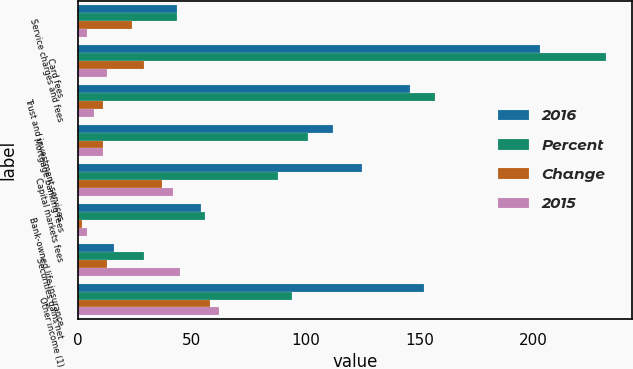Convert chart. <chart><loc_0><loc_0><loc_500><loc_500><stacked_bar_chart><ecel><fcel>Service charges and fees<fcel>Card fees<fcel>Trust and investment services<fcel>Mortgage banking fees<fcel>Capital markets fees<fcel>Bank-owned life insurance<fcel>Securities gains net<fcel>Other income (1)<nl><fcel>2016<fcel>43.5<fcel>203<fcel>146<fcel>112<fcel>125<fcel>54<fcel>16<fcel>152<nl><fcel>Percent<fcel>43.5<fcel>232<fcel>157<fcel>101<fcel>88<fcel>56<fcel>29<fcel>94<nl><fcel>Change<fcel>24<fcel>29<fcel>11<fcel>11<fcel>37<fcel>2<fcel>13<fcel>58<nl><fcel>2015<fcel>4<fcel>13<fcel>7<fcel>11<fcel>42<fcel>4<fcel>45<fcel>62<nl></chart> 